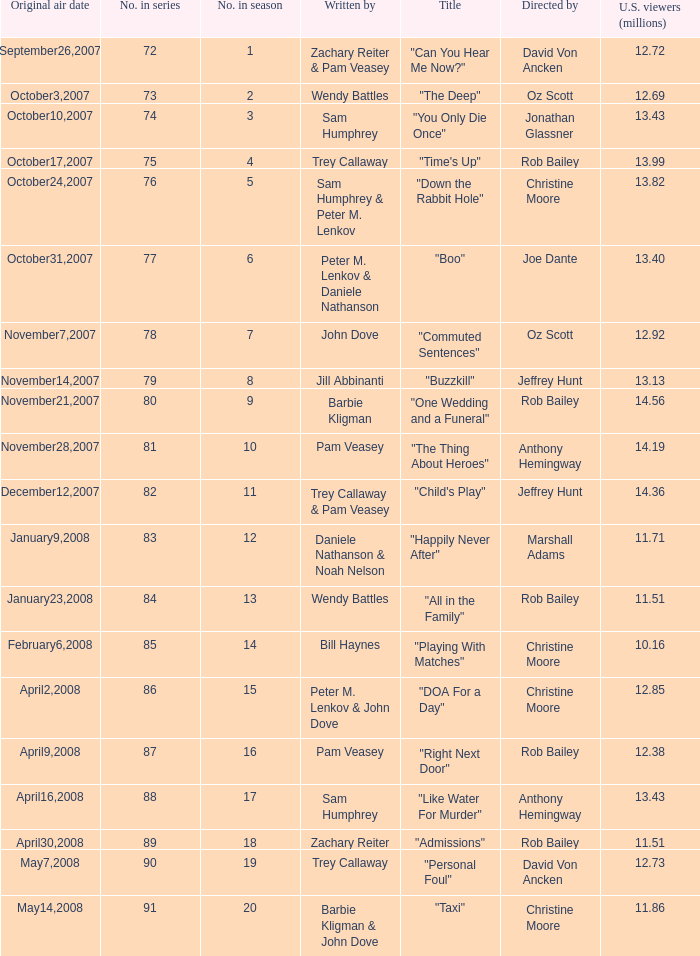How many millions of U.S. viewers watched the episode directed by Rob Bailey and written by Pam Veasey? 12.38. 